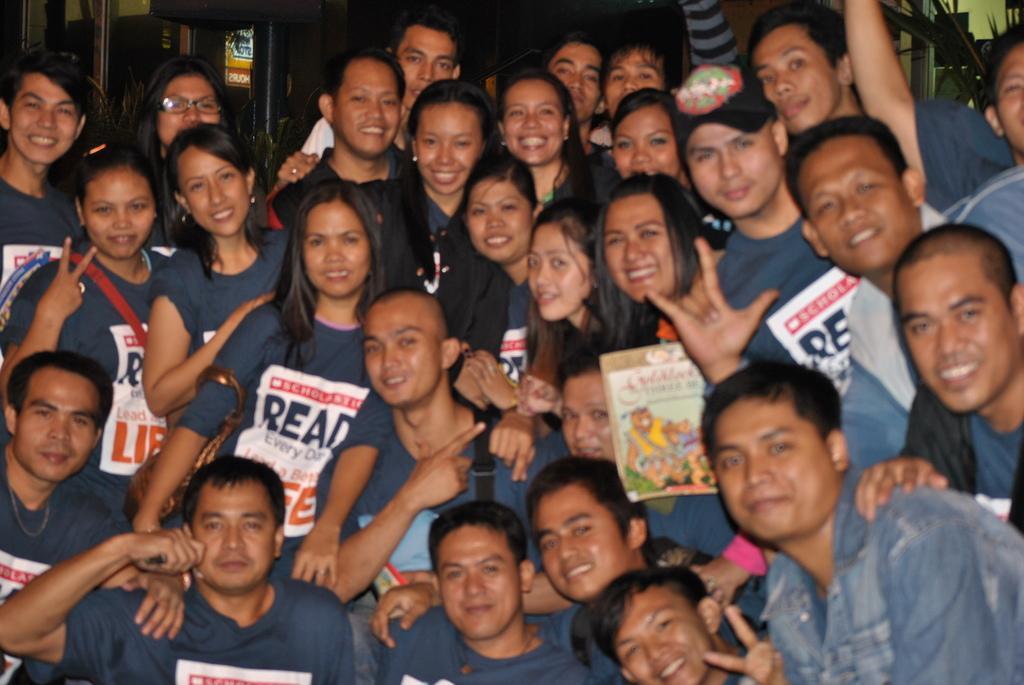Please provide a concise description of this image. In this image I can see group of people wearing blue color dress and I can see something written on the shirt. Background I can see few poles and a board in yellow color. 